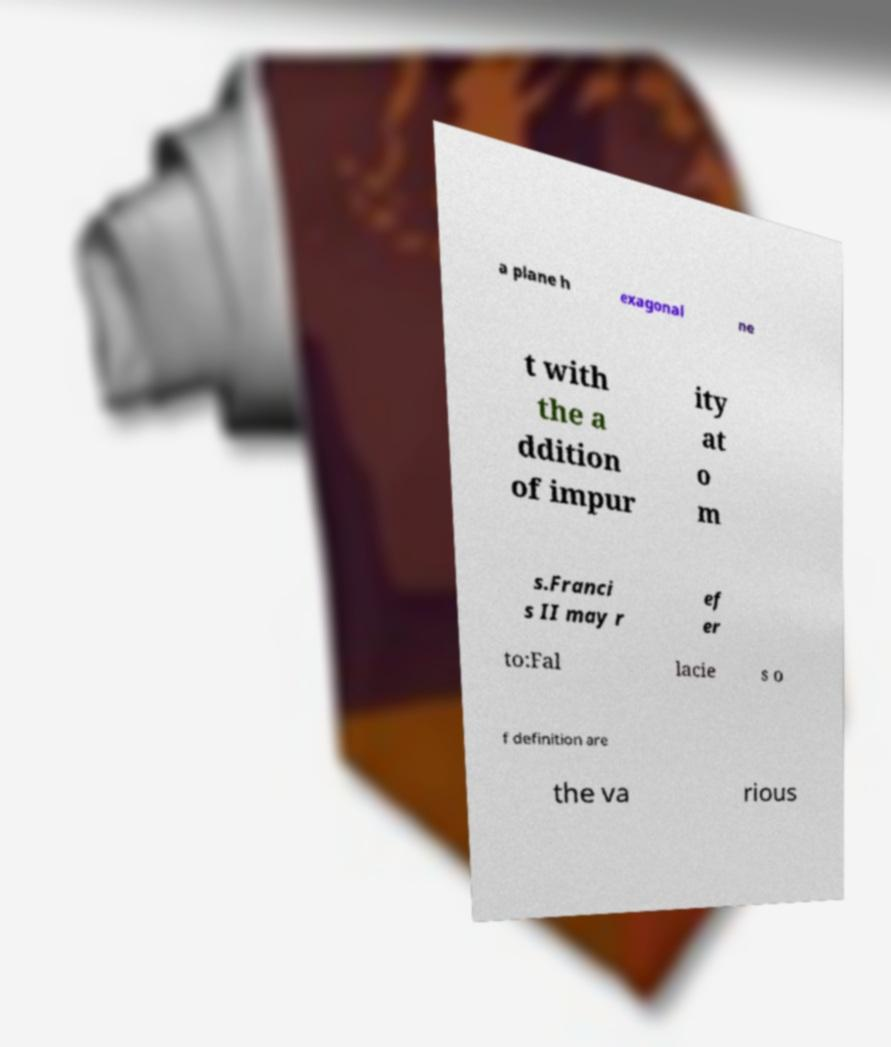There's text embedded in this image that I need extracted. Can you transcribe it verbatim? a plane h exagonal ne t with the a ddition of impur ity at o m s.Franci s II may r ef er to:Fal lacie s o f definition are the va rious 